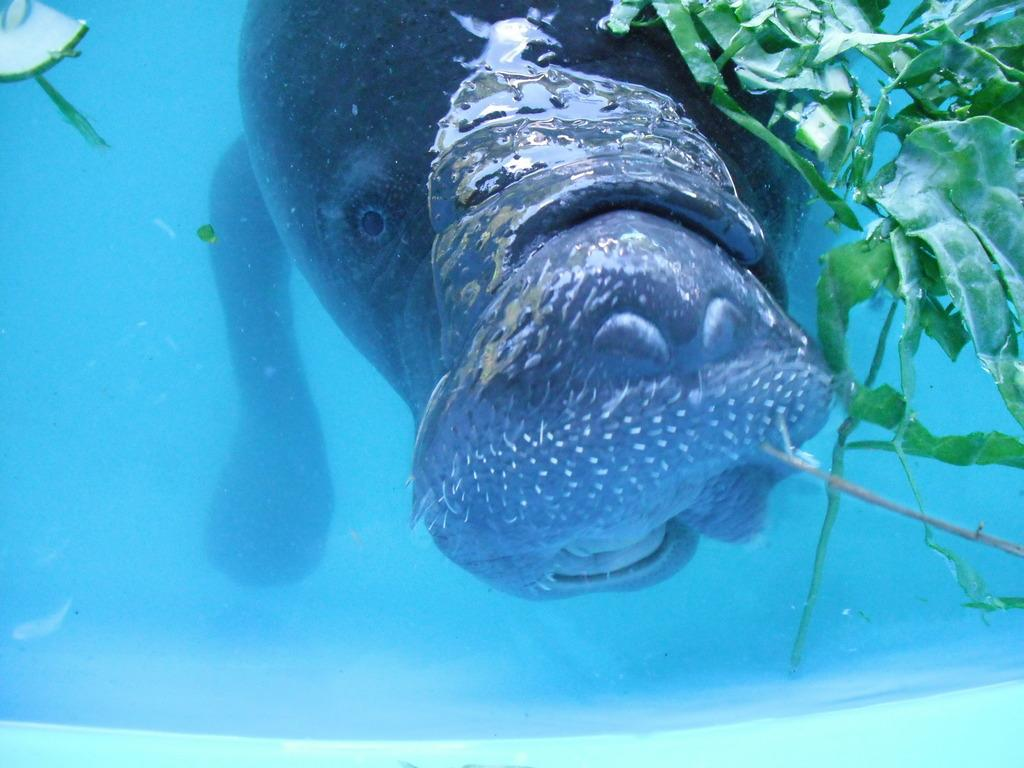What type of animal can be seen in the image? There is a water animal in the image. Where is the water animal located? The water animal is in the water. What other elements can be seen in the image? There are leaves visible in the image. Is the water animal afraid of the rainstorm in the image? There is no rainstorm present in the image, so it is not possible to determine if the water animal is afraid. 